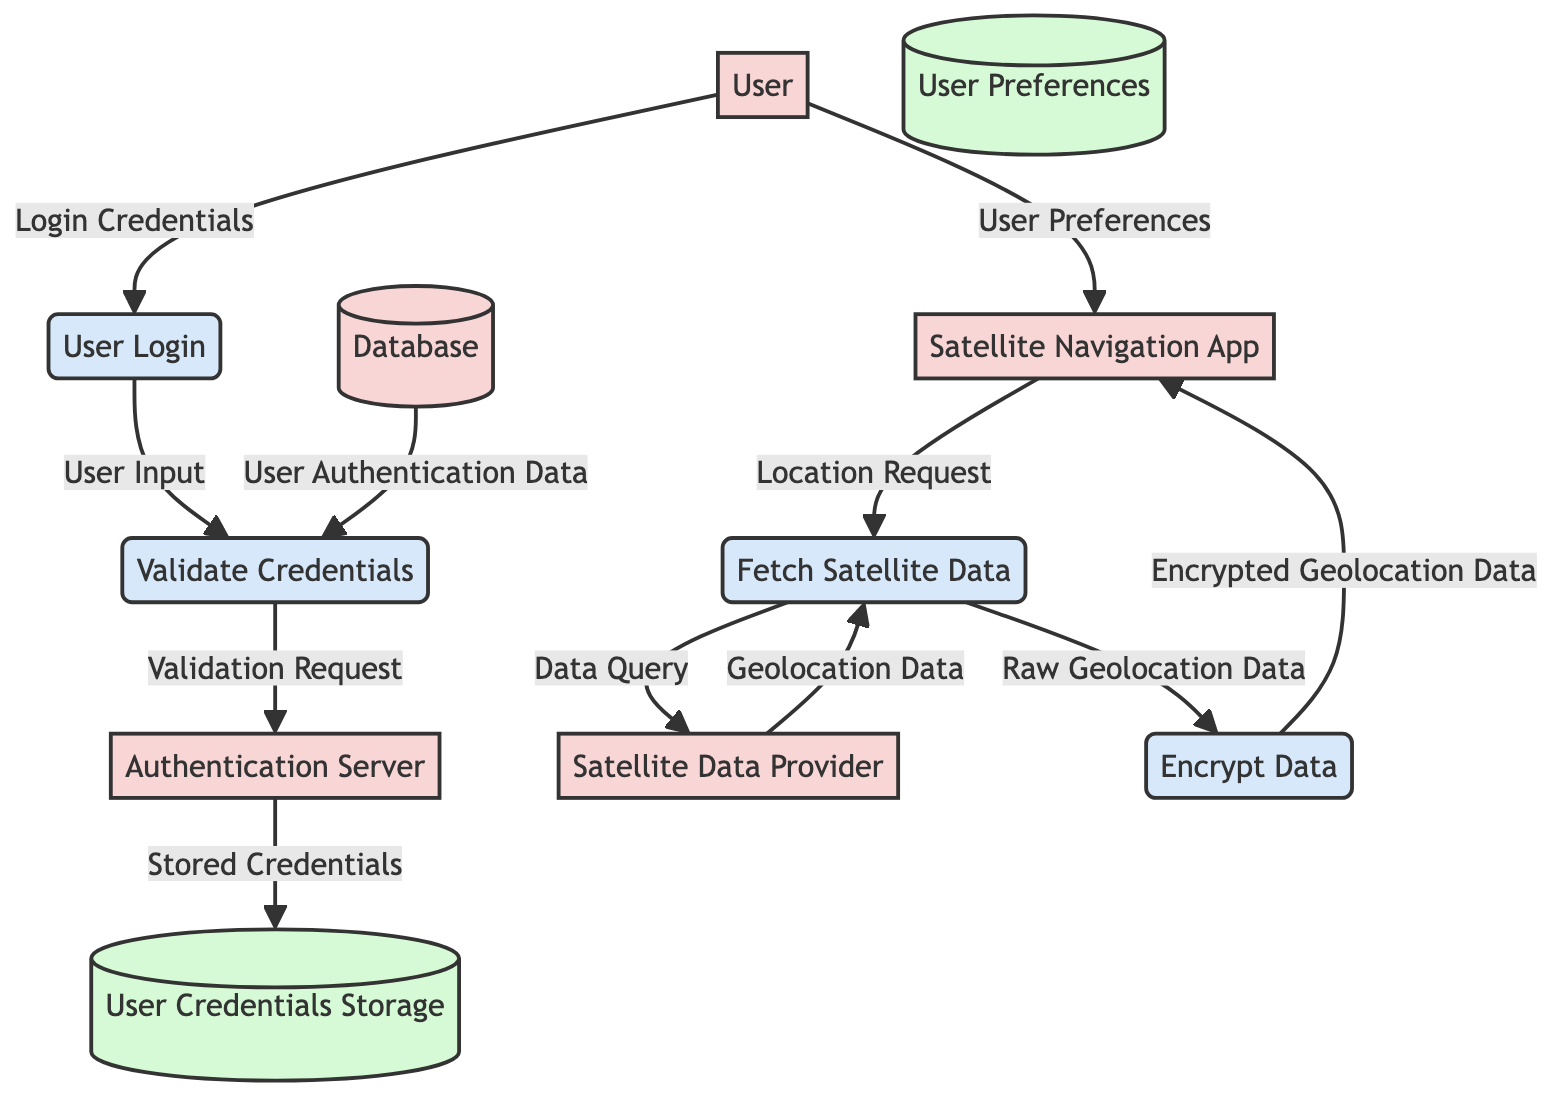What is the first process a user interacts with when logging in? The first process is the "User Login," which is initiated when the user provides their login credentials.
Answer: User Login How many entities are represented in the diagram? The entities listed are User, Satellite Navigation App, Authentication Server, Database, and Satellite Data Provider, which totals five entities.
Answer: Five What data flows from the "Authentication Server" to "User Credentials Storage"? The data that flows from the Authentication Server to User Credentials Storage is "Stored Credentials."
Answer: Stored Credentials What is the final process that the diagram depicts after fetching satellite data? The final process depicted after fetching satellite data is "Encrypt Data," where raw geolocation data is encrypted before being sent back to the satellite navigation app.
Answer: Encrypt Data Which entity provides geolocation data? The entity that provides geolocation data is the "Satellite Data Provider."
Answer: Satellite Data Provider What triggers the "Fetch Satellite Data" process? The "Location Request" from the "Satellite Navigation App" triggers the "Fetch Satellite Data" process.
Answer: Location Request What is the relationship between "User Preferences" and "Satellite Navigation App"? The "User Preferences" data flows from the User directly to the Satellite Navigation App, linking user-specific settings to the app's functionality.
Answer: User Preferences How does the "Validate Credentials" process acquire data? The "Validate Credentials" process acquires data by sending a "Validation Request" to the "Authentication Server" while also receiving "User Authentication Data" from the Database.
Answer: Validation Request What data does the "Fetch Satellite Data" process generate? The "Fetch Satellite Data" process generates "Geolocation Data" after querying the Satellite Data Provider.
Answer: Geolocation Data 